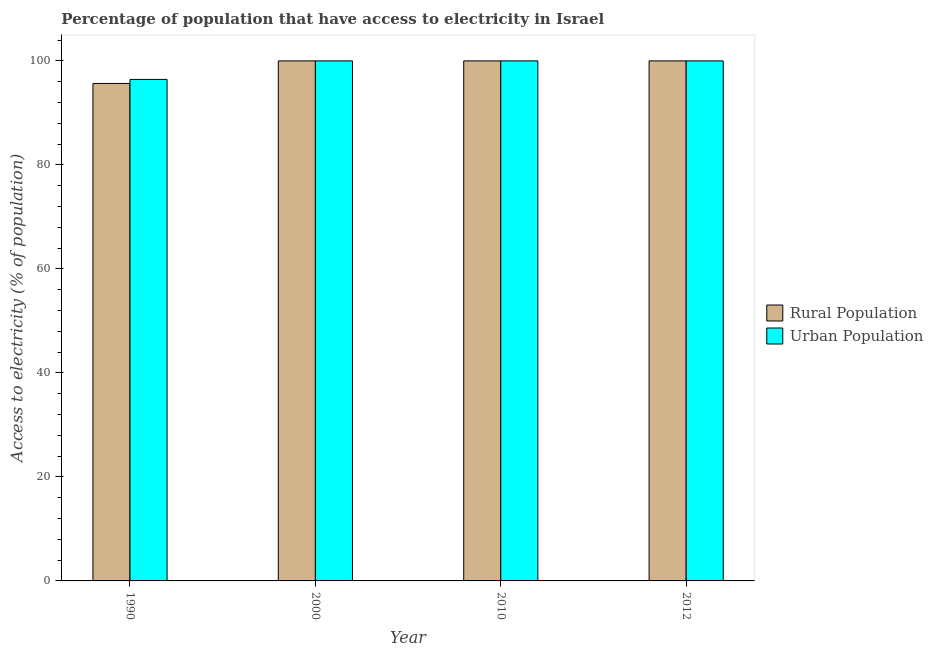How many groups of bars are there?
Provide a short and direct response. 4. Are the number of bars per tick equal to the number of legend labels?
Keep it short and to the point. Yes. How many bars are there on the 2nd tick from the left?
Give a very brief answer. 2. What is the label of the 1st group of bars from the left?
Provide a succinct answer. 1990. In how many cases, is the number of bars for a given year not equal to the number of legend labels?
Your answer should be very brief. 0. What is the percentage of urban population having access to electricity in 1990?
Keep it short and to the point. 96.44. Across all years, what is the maximum percentage of urban population having access to electricity?
Ensure brevity in your answer.  100. Across all years, what is the minimum percentage of urban population having access to electricity?
Make the answer very short. 96.44. In which year was the percentage of rural population having access to electricity maximum?
Provide a succinct answer. 2000. What is the total percentage of rural population having access to electricity in the graph?
Ensure brevity in your answer.  395.66. What is the difference between the percentage of urban population having access to electricity in 2000 and that in 2010?
Your answer should be very brief. 0. What is the average percentage of urban population having access to electricity per year?
Keep it short and to the point. 99.11. In the year 2012, what is the difference between the percentage of urban population having access to electricity and percentage of rural population having access to electricity?
Give a very brief answer. 0. In how many years, is the percentage of urban population having access to electricity greater than 100 %?
Offer a very short reply. 0. What is the ratio of the percentage of urban population having access to electricity in 1990 to that in 2000?
Ensure brevity in your answer.  0.96. Is the difference between the percentage of urban population having access to electricity in 2000 and 2012 greater than the difference between the percentage of rural population having access to electricity in 2000 and 2012?
Give a very brief answer. No. What is the difference between the highest and the lowest percentage of urban population having access to electricity?
Provide a succinct answer. 3.56. What does the 1st bar from the left in 1990 represents?
Offer a very short reply. Rural Population. What does the 2nd bar from the right in 2010 represents?
Ensure brevity in your answer.  Rural Population. Are all the bars in the graph horizontal?
Offer a very short reply. No. What is the difference between two consecutive major ticks on the Y-axis?
Your answer should be very brief. 20. Does the graph contain grids?
Offer a very short reply. No. Where does the legend appear in the graph?
Make the answer very short. Center right. What is the title of the graph?
Your response must be concise. Percentage of population that have access to electricity in Israel. Does "Travel Items" appear as one of the legend labels in the graph?
Offer a terse response. No. What is the label or title of the Y-axis?
Make the answer very short. Access to electricity (% of population). What is the Access to electricity (% of population) of Rural Population in 1990?
Provide a short and direct response. 95.66. What is the Access to electricity (% of population) of Urban Population in 1990?
Your answer should be very brief. 96.44. What is the Access to electricity (% of population) in Rural Population in 2000?
Ensure brevity in your answer.  100. What is the Access to electricity (% of population) of Urban Population in 2000?
Keep it short and to the point. 100. What is the Access to electricity (% of population) in Rural Population in 2010?
Your answer should be very brief. 100. What is the Access to electricity (% of population) in Urban Population in 2010?
Your answer should be very brief. 100. What is the Access to electricity (% of population) in Rural Population in 2012?
Your answer should be compact. 100. Across all years, what is the maximum Access to electricity (% of population) in Rural Population?
Your answer should be very brief. 100. Across all years, what is the maximum Access to electricity (% of population) in Urban Population?
Keep it short and to the point. 100. Across all years, what is the minimum Access to electricity (% of population) in Rural Population?
Offer a very short reply. 95.66. Across all years, what is the minimum Access to electricity (% of population) in Urban Population?
Keep it short and to the point. 96.44. What is the total Access to electricity (% of population) of Rural Population in the graph?
Your answer should be very brief. 395.66. What is the total Access to electricity (% of population) of Urban Population in the graph?
Provide a short and direct response. 396.44. What is the difference between the Access to electricity (% of population) of Rural Population in 1990 and that in 2000?
Your answer should be very brief. -4.34. What is the difference between the Access to electricity (% of population) of Urban Population in 1990 and that in 2000?
Offer a very short reply. -3.56. What is the difference between the Access to electricity (% of population) in Rural Population in 1990 and that in 2010?
Your response must be concise. -4.34. What is the difference between the Access to electricity (% of population) in Urban Population in 1990 and that in 2010?
Keep it short and to the point. -3.56. What is the difference between the Access to electricity (% of population) in Rural Population in 1990 and that in 2012?
Ensure brevity in your answer.  -4.34. What is the difference between the Access to electricity (% of population) of Urban Population in 1990 and that in 2012?
Provide a succinct answer. -3.56. What is the difference between the Access to electricity (% of population) of Rural Population in 2000 and that in 2010?
Your response must be concise. 0. What is the difference between the Access to electricity (% of population) in Rural Population in 2000 and that in 2012?
Your response must be concise. 0. What is the difference between the Access to electricity (% of population) in Urban Population in 2000 and that in 2012?
Make the answer very short. 0. What is the difference between the Access to electricity (% of population) in Rural Population in 1990 and the Access to electricity (% of population) in Urban Population in 2000?
Give a very brief answer. -4.34. What is the difference between the Access to electricity (% of population) of Rural Population in 1990 and the Access to electricity (% of population) of Urban Population in 2010?
Provide a short and direct response. -4.34. What is the difference between the Access to electricity (% of population) in Rural Population in 1990 and the Access to electricity (% of population) in Urban Population in 2012?
Offer a terse response. -4.34. What is the difference between the Access to electricity (% of population) in Rural Population in 2000 and the Access to electricity (% of population) in Urban Population in 2012?
Keep it short and to the point. 0. What is the difference between the Access to electricity (% of population) in Rural Population in 2010 and the Access to electricity (% of population) in Urban Population in 2012?
Your answer should be very brief. 0. What is the average Access to electricity (% of population) in Rural Population per year?
Offer a terse response. 98.92. What is the average Access to electricity (% of population) of Urban Population per year?
Provide a succinct answer. 99.11. In the year 1990, what is the difference between the Access to electricity (% of population) in Rural Population and Access to electricity (% of population) in Urban Population?
Ensure brevity in your answer.  -0.78. In the year 2000, what is the difference between the Access to electricity (% of population) in Rural Population and Access to electricity (% of population) in Urban Population?
Keep it short and to the point. 0. In the year 2012, what is the difference between the Access to electricity (% of population) in Rural Population and Access to electricity (% of population) in Urban Population?
Your answer should be compact. 0. What is the ratio of the Access to electricity (% of population) of Rural Population in 1990 to that in 2000?
Your response must be concise. 0.96. What is the ratio of the Access to electricity (% of population) of Urban Population in 1990 to that in 2000?
Offer a very short reply. 0.96. What is the ratio of the Access to electricity (% of population) in Rural Population in 1990 to that in 2010?
Your response must be concise. 0.96. What is the ratio of the Access to electricity (% of population) of Urban Population in 1990 to that in 2010?
Your answer should be very brief. 0.96. What is the ratio of the Access to electricity (% of population) of Rural Population in 1990 to that in 2012?
Provide a short and direct response. 0.96. What is the ratio of the Access to electricity (% of population) of Urban Population in 1990 to that in 2012?
Your response must be concise. 0.96. What is the ratio of the Access to electricity (% of population) of Rural Population in 2000 to that in 2010?
Offer a very short reply. 1. What is the ratio of the Access to electricity (% of population) of Rural Population in 2000 to that in 2012?
Offer a terse response. 1. What is the ratio of the Access to electricity (% of population) in Urban Population in 2000 to that in 2012?
Make the answer very short. 1. What is the ratio of the Access to electricity (% of population) of Urban Population in 2010 to that in 2012?
Provide a short and direct response. 1. What is the difference between the highest and the second highest Access to electricity (% of population) of Rural Population?
Give a very brief answer. 0. What is the difference between the highest and the lowest Access to electricity (% of population) of Rural Population?
Offer a very short reply. 4.34. What is the difference between the highest and the lowest Access to electricity (% of population) in Urban Population?
Make the answer very short. 3.56. 